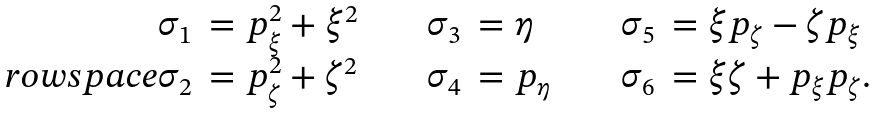Convert formula to latex. <formula><loc_0><loc_0><loc_500><loc_500>\begin{array} { r l c r l c r l } { \sigma } _ { 1 } & = p ^ { 2 } _ { \xi } + { \xi } ^ { 2 } & \quad & { \sigma } _ { 3 } & = \eta & \quad & { \sigma } _ { 5 } & = \xi p _ { \zeta } - \zeta p _ { \xi } \\ \ r o w s p a c e { \sigma } _ { 2 } & = p ^ { 2 } _ { \zeta } + { \zeta } ^ { 2 } & \quad & { \sigma } _ { 4 } & = p _ { \eta } & \quad & { \sigma } _ { 6 } & = \xi { \zeta } + p _ { \xi } p _ { \zeta } . \end{array}</formula> 